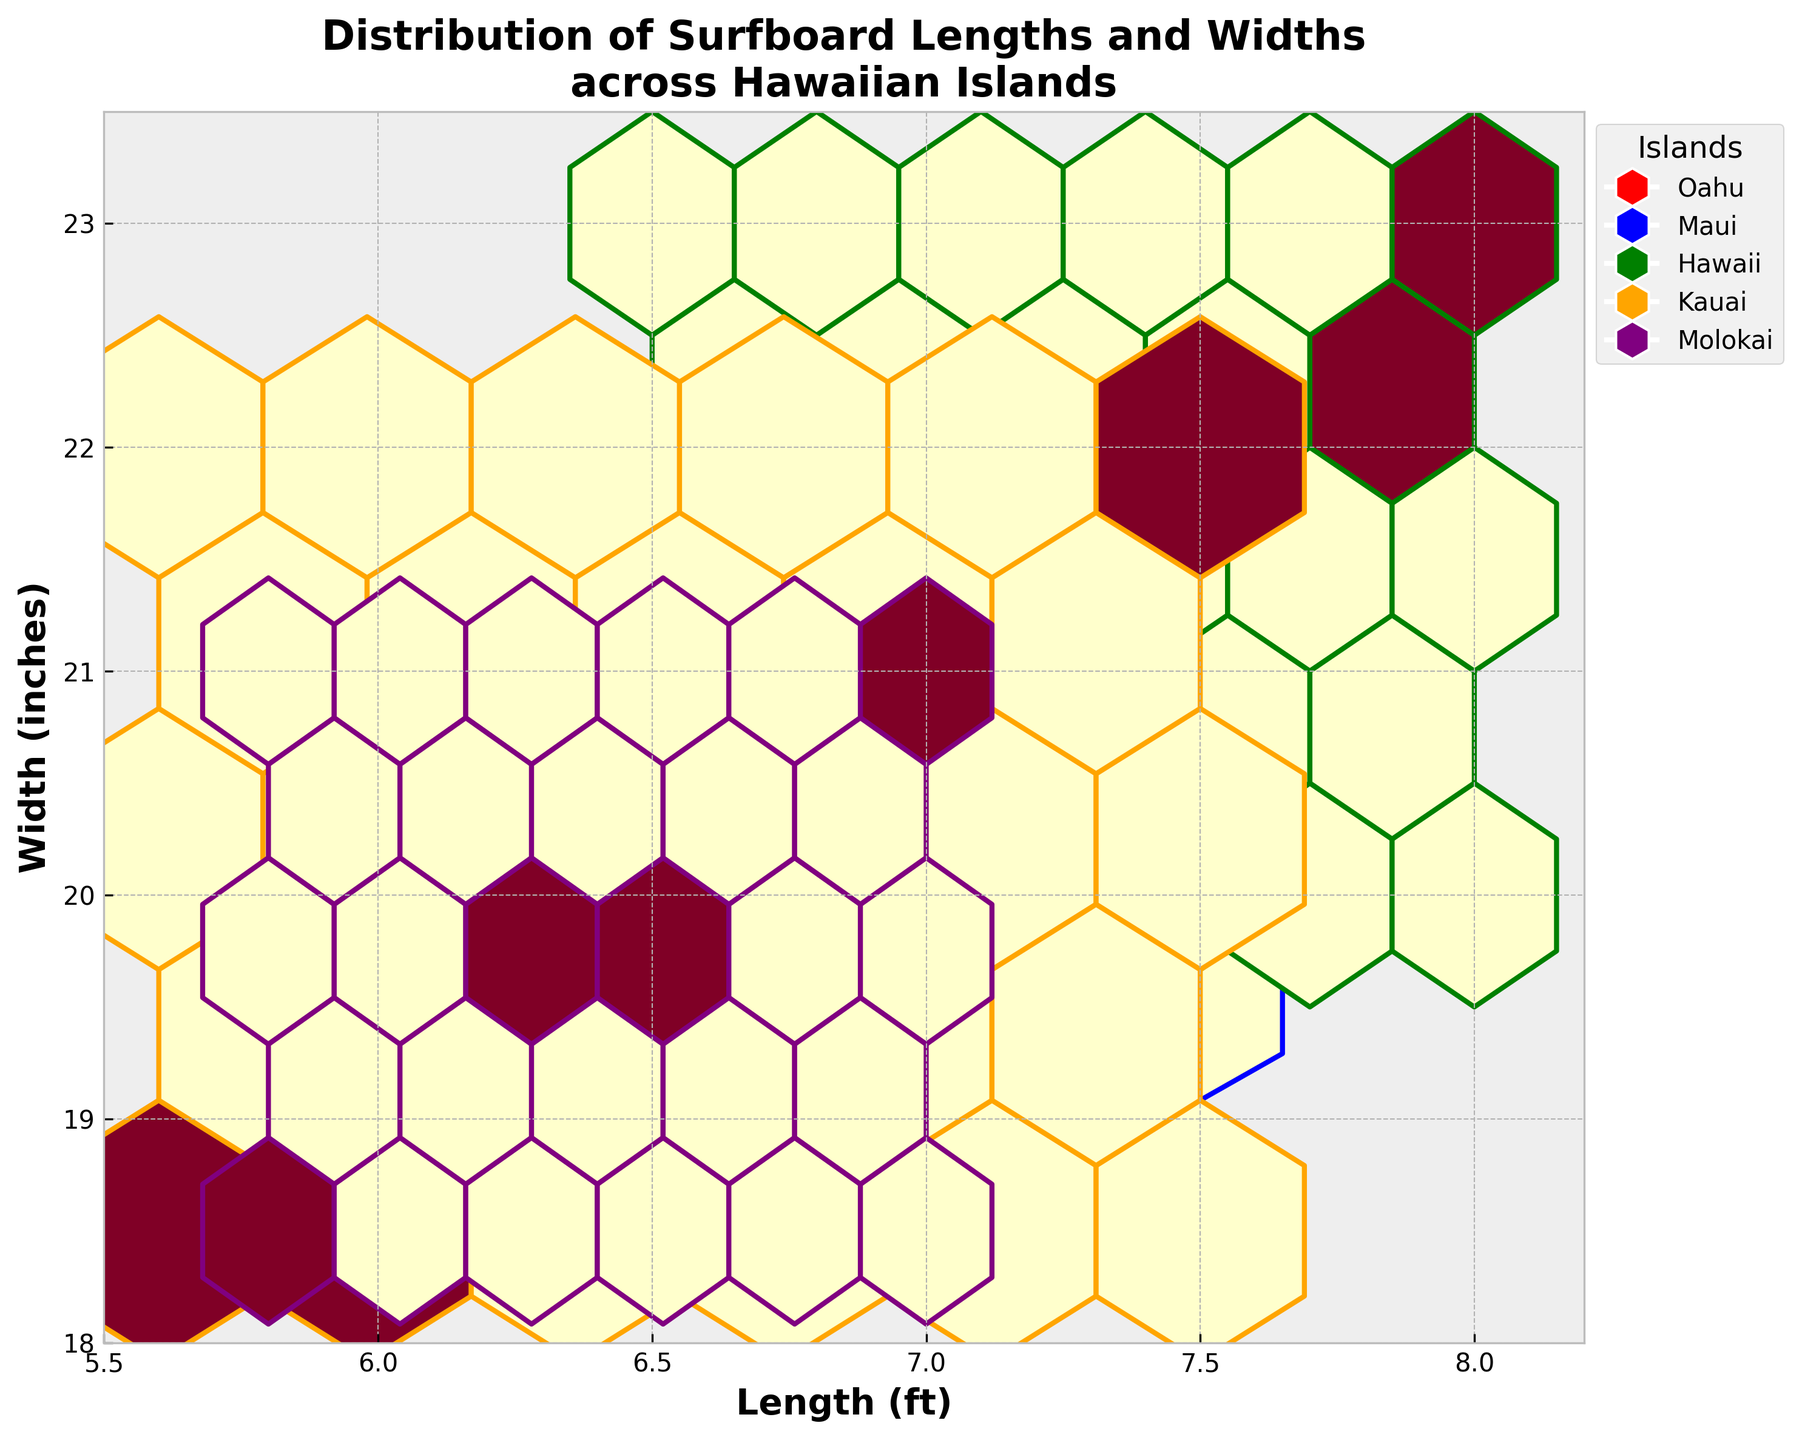What's the title of the plot? The title is usually located at the top of the plot and provides an overview of what the plot represents. In this case, it states "Distribution of Surfboard Lengths and Widths across Hawaiian Islands."
Answer: Distribution of Surfboard Lengths and Widths across Hawaiian Islands What range of surfboard lengths is displayed on the x-axis? The x-axis typically shows the range of surfboard lengths in feet. By looking at the plot, the range is given from 5.5 to 8.2 feet.
Answer: 5.5 to 8.2 feet Which island has the surfboard with the longest length? By examining the hexagonal bins on the plot, Hawaii has surfboards as long as 8.0 feet, which is the maximum length displayed.
Answer: Hawaii Between which widths (in inches) does Kauai's widest surfboard fall? Kauai's surfboards appear in the hexagonal bins representing widths up to 22 inches. Checking the labels, it is between 18.5 and 22 inches.
Answer: 18.5 to 22 inches Which island consistently has the narrowest surfboards compared to others? By comparing the bins horizontally, Molokai's surfboards appear with widths down to 18.5 inches, which is the smallest.
Answer: Molokai What is the maximum width displayed on the y-axis? The y-axis ranges from 18 to 23.5 inches, so the maximum width is 23.5 inches.
Answer: 23.5 inches How many different grid colors (island colors) are shown in the hexbin plot? Each different color represents a different island, and there are five unique colors visible, corresponding to Oahu, Maui, Hawaii, Kauai, and Molokai.
Answer: 5 Which island's surfboards have both the longest length and the widest width? Observing the hexagonal bins, Hawaii's surfboards appear to have lengths up to 8.0 feet and widths up to 23 inches, making them the longest and widest.
Answer: Hawaii Are Maui's surfboards generally longer or wider compared to those from Kauai? By comparing Maui and Kauai within the bins, Maui's surfboards fall in a range that includes longer surfboards up to 7.5 feet, while Kauai's extend to 7.5 feet but are generally narrower.
Answer: Longer 